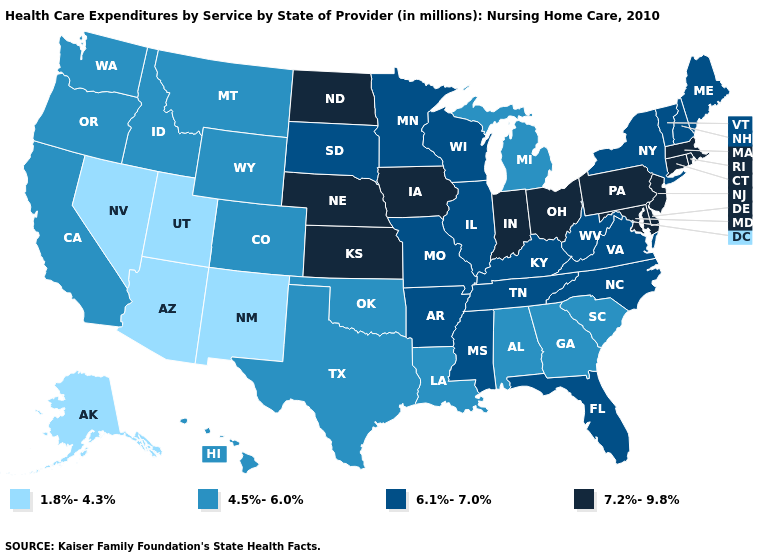Name the states that have a value in the range 4.5%-6.0%?
Be succinct. Alabama, California, Colorado, Georgia, Hawaii, Idaho, Louisiana, Michigan, Montana, Oklahoma, Oregon, South Carolina, Texas, Washington, Wyoming. What is the lowest value in states that border Michigan?
Quick response, please. 6.1%-7.0%. How many symbols are there in the legend?
Quick response, please. 4. What is the value of Montana?
Keep it brief. 4.5%-6.0%. What is the lowest value in the West?
Be succinct. 1.8%-4.3%. Which states have the lowest value in the West?
Keep it brief. Alaska, Arizona, Nevada, New Mexico, Utah. What is the value of Arkansas?
Give a very brief answer. 6.1%-7.0%. Which states have the lowest value in the Northeast?
Short answer required. Maine, New Hampshire, New York, Vermont. Among the states that border Kentucky , does Missouri have the lowest value?
Be succinct. Yes. Name the states that have a value in the range 7.2%-9.8%?
Answer briefly. Connecticut, Delaware, Indiana, Iowa, Kansas, Maryland, Massachusetts, Nebraska, New Jersey, North Dakota, Ohio, Pennsylvania, Rhode Island. Does Minnesota have the same value as Wyoming?
Give a very brief answer. No. Does the map have missing data?
Keep it brief. No. What is the value of South Dakota?
Quick response, please. 6.1%-7.0%. Does Alabama have the lowest value in the South?
Give a very brief answer. Yes. Name the states that have a value in the range 1.8%-4.3%?
Write a very short answer. Alaska, Arizona, Nevada, New Mexico, Utah. 